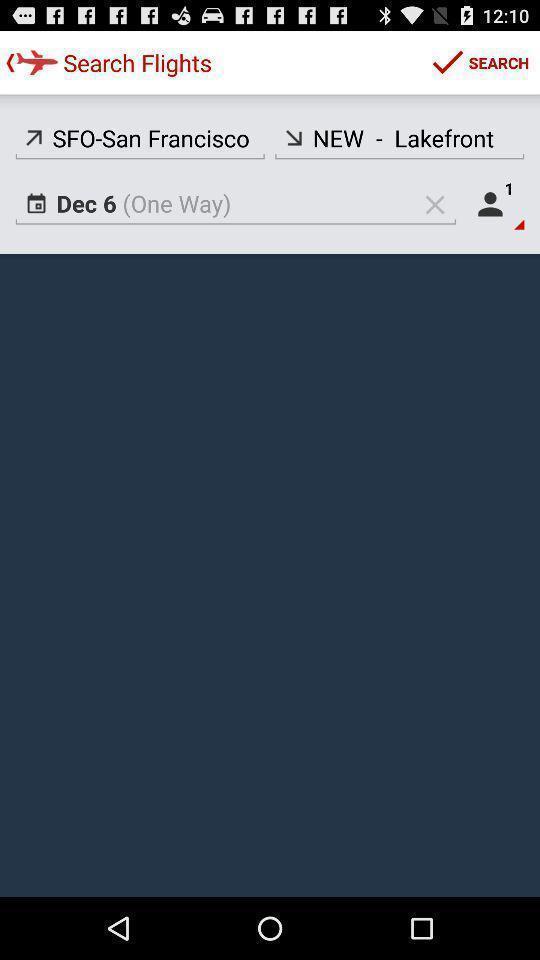Explain the elements present in this screenshot. Search page for searching a flights. 